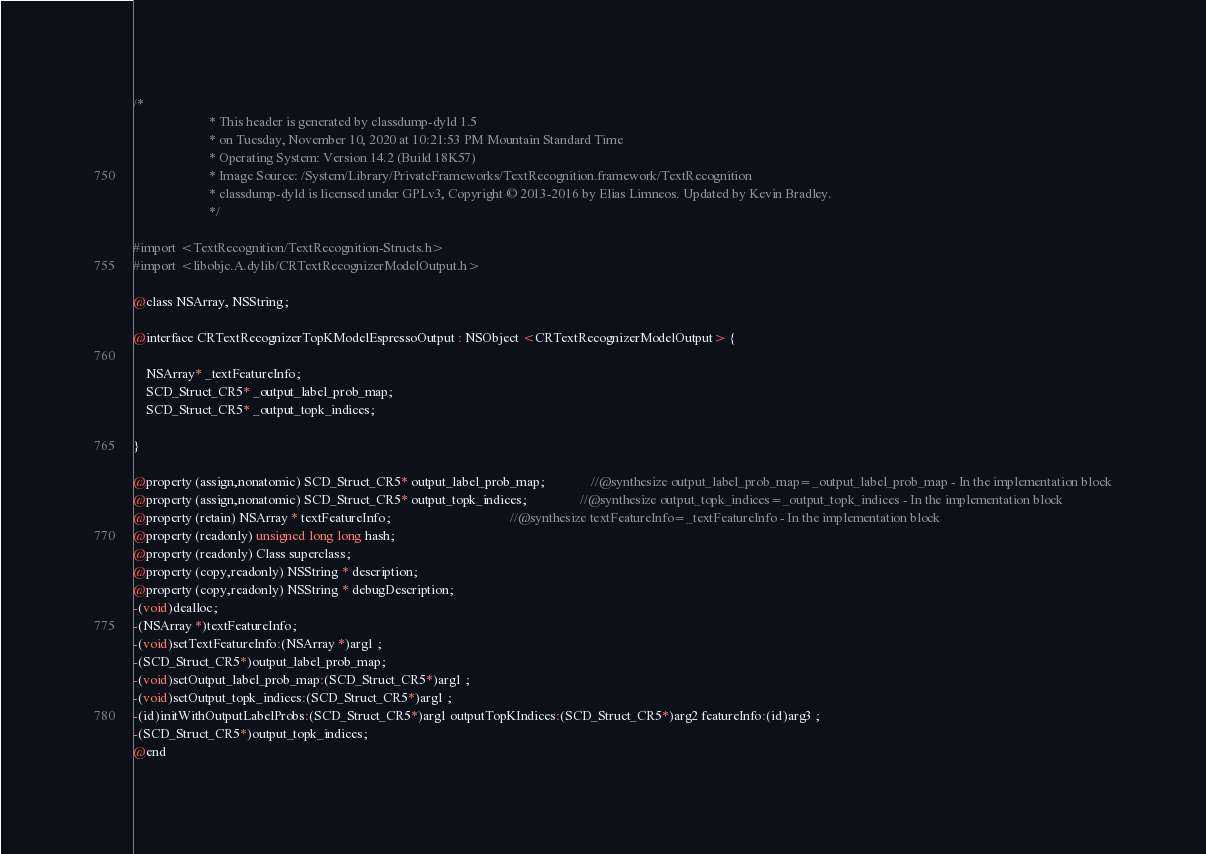Convert code to text. <code><loc_0><loc_0><loc_500><loc_500><_C_>/*
                       * This header is generated by classdump-dyld 1.5
                       * on Tuesday, November 10, 2020 at 10:21:53 PM Mountain Standard Time
                       * Operating System: Version 14.2 (Build 18K57)
                       * Image Source: /System/Library/PrivateFrameworks/TextRecognition.framework/TextRecognition
                       * classdump-dyld is licensed under GPLv3, Copyright © 2013-2016 by Elias Limneos. Updated by Kevin Bradley.
                       */

#import <TextRecognition/TextRecognition-Structs.h>
#import <libobjc.A.dylib/CRTextRecognizerModelOutput.h>

@class NSArray, NSString;

@interface CRTextRecognizerTopKModelEspressoOutput : NSObject <CRTextRecognizerModelOutput> {

	NSArray* _textFeatureInfo;
	SCD_Struct_CR5* _output_label_prob_map;
	SCD_Struct_CR5* _output_topk_indices;

}

@property (assign,nonatomic) SCD_Struct_CR5* output_label_prob_map;              //@synthesize output_label_prob_map=_output_label_prob_map - In the implementation block
@property (assign,nonatomic) SCD_Struct_CR5* output_topk_indices;                //@synthesize output_topk_indices=_output_topk_indices - In the implementation block
@property (retain) NSArray * textFeatureInfo;                                    //@synthesize textFeatureInfo=_textFeatureInfo - In the implementation block
@property (readonly) unsigned long long hash; 
@property (readonly) Class superclass; 
@property (copy,readonly) NSString * description; 
@property (copy,readonly) NSString * debugDescription; 
-(void)dealloc;
-(NSArray *)textFeatureInfo;
-(void)setTextFeatureInfo:(NSArray *)arg1 ;
-(SCD_Struct_CR5*)output_label_prob_map;
-(void)setOutput_label_prob_map:(SCD_Struct_CR5*)arg1 ;
-(void)setOutput_topk_indices:(SCD_Struct_CR5*)arg1 ;
-(id)initWithOutputLabelProbs:(SCD_Struct_CR5*)arg1 outputTopKIndices:(SCD_Struct_CR5*)arg2 featureInfo:(id)arg3 ;
-(SCD_Struct_CR5*)output_topk_indices;
@end

</code> 